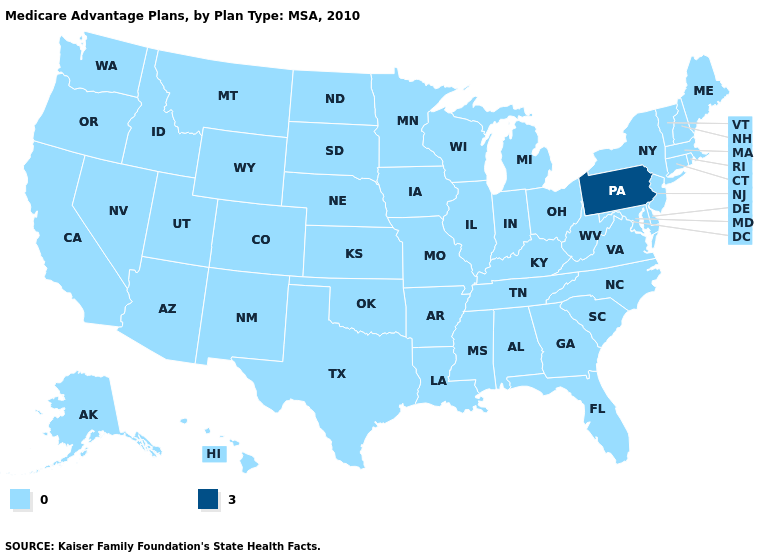Which states have the lowest value in the USA?
Write a very short answer. Alaska, Alabama, Arkansas, Arizona, California, Colorado, Connecticut, Delaware, Florida, Georgia, Hawaii, Iowa, Idaho, Illinois, Indiana, Kansas, Kentucky, Louisiana, Massachusetts, Maryland, Maine, Michigan, Minnesota, Missouri, Mississippi, Montana, North Carolina, North Dakota, Nebraska, New Hampshire, New Jersey, New Mexico, Nevada, New York, Ohio, Oklahoma, Oregon, Rhode Island, South Carolina, South Dakota, Tennessee, Texas, Utah, Virginia, Vermont, Washington, Wisconsin, West Virginia, Wyoming. What is the value of Idaho?
Write a very short answer. 0. What is the value of Nebraska?
Be succinct. 0. What is the value of Tennessee?
Give a very brief answer. 0. Does North Carolina have the same value as Nevada?
Answer briefly. Yes. What is the lowest value in states that border Virginia?
Write a very short answer. 0. Name the states that have a value in the range 3?
Write a very short answer. Pennsylvania. Which states have the lowest value in the USA?
Quick response, please. Alaska, Alabama, Arkansas, Arizona, California, Colorado, Connecticut, Delaware, Florida, Georgia, Hawaii, Iowa, Idaho, Illinois, Indiana, Kansas, Kentucky, Louisiana, Massachusetts, Maryland, Maine, Michigan, Minnesota, Missouri, Mississippi, Montana, North Carolina, North Dakota, Nebraska, New Hampshire, New Jersey, New Mexico, Nevada, New York, Ohio, Oklahoma, Oregon, Rhode Island, South Carolina, South Dakota, Tennessee, Texas, Utah, Virginia, Vermont, Washington, Wisconsin, West Virginia, Wyoming. What is the value of Michigan?
Quick response, please. 0. Name the states that have a value in the range 0?
Quick response, please. Alaska, Alabama, Arkansas, Arizona, California, Colorado, Connecticut, Delaware, Florida, Georgia, Hawaii, Iowa, Idaho, Illinois, Indiana, Kansas, Kentucky, Louisiana, Massachusetts, Maryland, Maine, Michigan, Minnesota, Missouri, Mississippi, Montana, North Carolina, North Dakota, Nebraska, New Hampshire, New Jersey, New Mexico, Nevada, New York, Ohio, Oklahoma, Oregon, Rhode Island, South Carolina, South Dakota, Tennessee, Texas, Utah, Virginia, Vermont, Washington, Wisconsin, West Virginia, Wyoming. Name the states that have a value in the range 3?
Answer briefly. Pennsylvania. What is the value of Rhode Island?
Give a very brief answer. 0. Name the states that have a value in the range 3?
Quick response, please. Pennsylvania. What is the highest value in the West ?
Be succinct. 0. What is the value of Wyoming?
Write a very short answer. 0. 